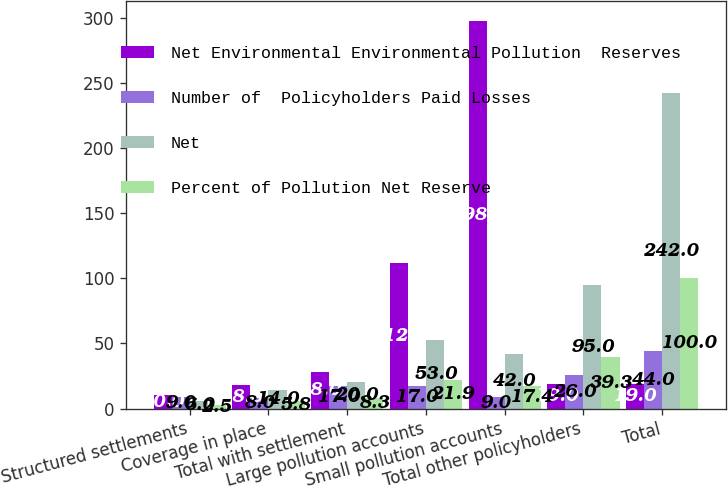<chart> <loc_0><loc_0><loc_500><loc_500><stacked_bar_chart><ecel><fcel>Structured settlements<fcel>Coverage in place<fcel>Total with settlement<fcel>Large pollution accounts<fcel>Small pollution accounts<fcel>Total other policyholders<fcel>Total<nl><fcel>Net Environmental Environmental Pollution  Reserves<fcel>10<fcel>18<fcel>28<fcel>112<fcel>298<fcel>19<fcel>19<nl><fcel>Number of  Policyholders Paid Losses<fcel>9<fcel>8<fcel>17<fcel>17<fcel>9<fcel>26<fcel>44<nl><fcel>Net<fcel>6<fcel>14<fcel>20<fcel>53<fcel>42<fcel>95<fcel>242<nl><fcel>Percent of Pollution Net Reserve<fcel>2.5<fcel>5.8<fcel>8.3<fcel>21.9<fcel>17.4<fcel>39.3<fcel>100<nl></chart> 